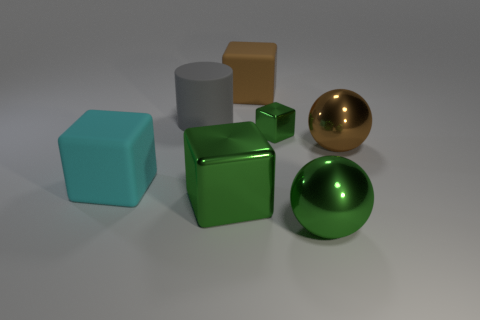What color is the tiny metal cube?
Your response must be concise. Green. There is a big sphere behind the large green cube left of the large brown matte block; what is its color?
Make the answer very short. Brown. The large green metal thing right of the brown object behind the brown thing in front of the small metal thing is what shape?
Provide a short and direct response. Sphere. What number of green cubes are the same material as the large cyan block?
Provide a short and direct response. 0. How many brown spheres are to the right of the ball behind the big green cube?
Give a very brief answer. 0. What number of yellow blocks are there?
Keep it short and to the point. 0. Is the large brown sphere made of the same material as the large green object that is to the left of the big green sphere?
Your answer should be compact. Yes. There is a metal block that is to the left of the small metal thing; is its color the same as the tiny thing?
Ensure brevity in your answer.  Yes. What material is the big thing that is behind the small block and right of the big gray rubber cylinder?
Provide a short and direct response. Rubber. What is the size of the cyan matte object?
Your answer should be compact. Large. 